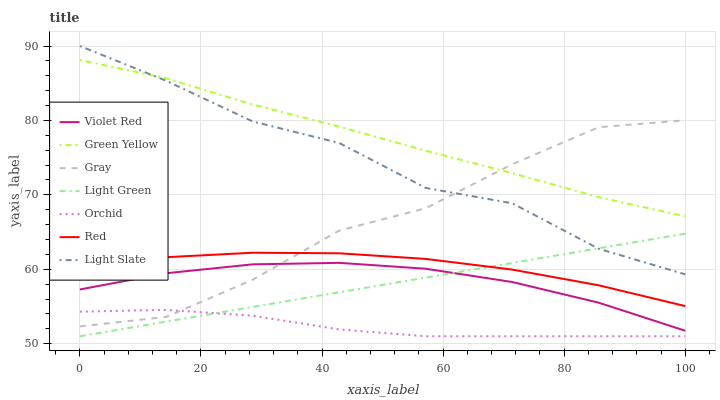Does Orchid have the minimum area under the curve?
Answer yes or no. Yes. Does Green Yellow have the maximum area under the curve?
Answer yes or no. Yes. Does Violet Red have the minimum area under the curve?
Answer yes or no. No. Does Violet Red have the maximum area under the curve?
Answer yes or no. No. Is Light Green the smoothest?
Answer yes or no. Yes. Is Light Slate the roughest?
Answer yes or no. Yes. Is Violet Red the smoothest?
Answer yes or no. No. Is Violet Red the roughest?
Answer yes or no. No. Does Light Green have the lowest value?
Answer yes or no. Yes. Does Violet Red have the lowest value?
Answer yes or no. No. Does Light Slate have the highest value?
Answer yes or no. Yes. Does Violet Red have the highest value?
Answer yes or no. No. Is Red less than Light Slate?
Answer yes or no. Yes. Is Red greater than Violet Red?
Answer yes or no. Yes. Does Light Slate intersect Gray?
Answer yes or no. Yes. Is Light Slate less than Gray?
Answer yes or no. No. Is Light Slate greater than Gray?
Answer yes or no. No. Does Red intersect Light Slate?
Answer yes or no. No. 